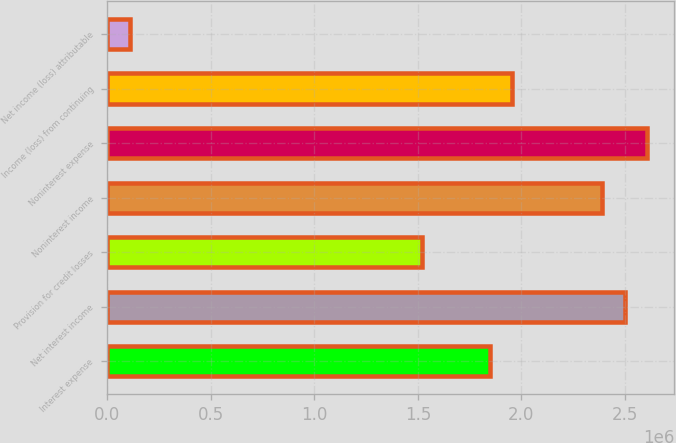Convert chart to OTSL. <chart><loc_0><loc_0><loc_500><loc_500><bar_chart><fcel>Interest expense<fcel>Net interest income<fcel>Provision for credit losses<fcel>Noninterest income<fcel>Noninterest expense<fcel>Income (loss) from continuing<fcel>Net income (loss) attributable<nl><fcel>1.84712e+06<fcel>2.49904e+06<fcel>1.52116e+06<fcel>2.39039e+06<fcel>2.6077e+06<fcel>1.95577e+06<fcel>108654<nl></chart> 